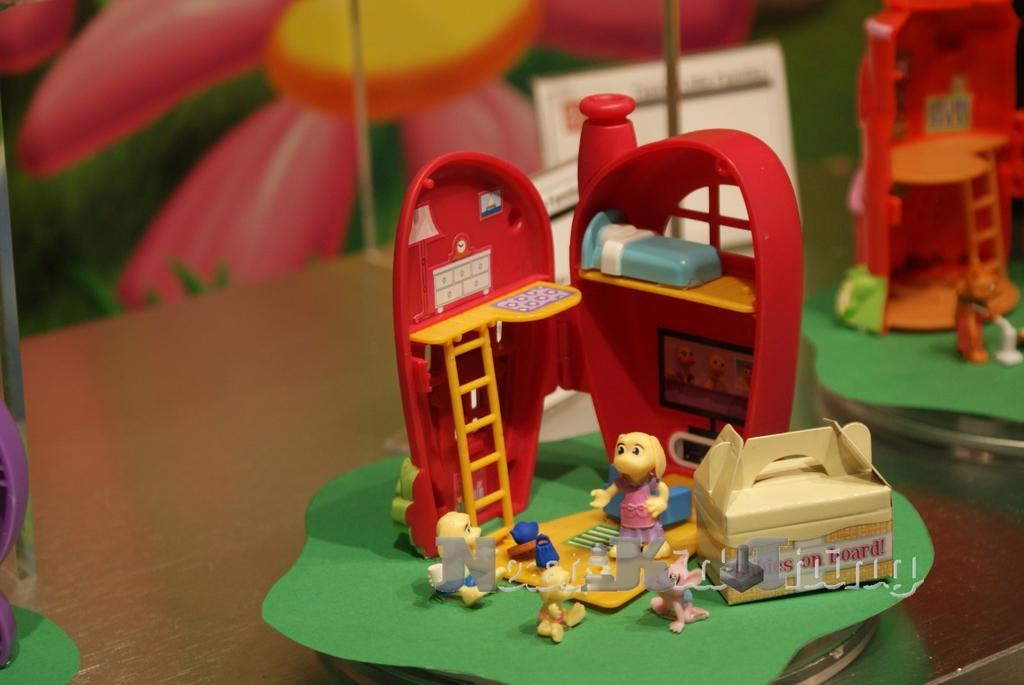What is located on the platform in the image? There are toys and objects on a platform in the image. Can you describe the background of the image? There is an image of a flower in the background of the image. What type of wine is being served in the image? There is no wine present in the image; it features toys and objects on a platform with a flower image in the background. How much does the giraffe weigh in the image? There is no giraffe present in the image. 